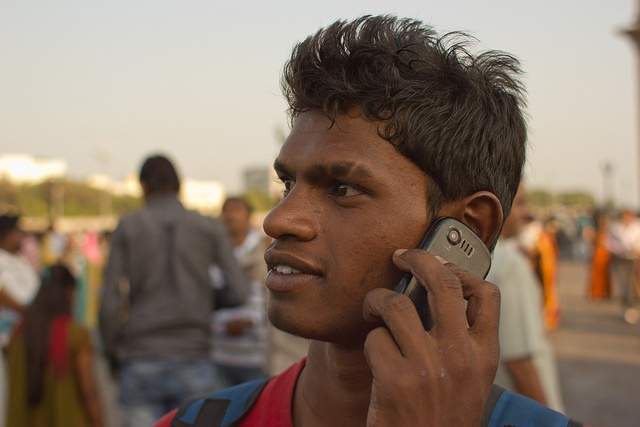Describe the objects in this image and their specific colors. I can see people in lightgray, black, maroon, brown, and gray tones, people in lightgray, gray, and black tones, people in lightgray, maroon, black, and gray tones, people in lightgray, tan, gray, and maroon tones, and people in lightgray, gray, black, and brown tones in this image. 